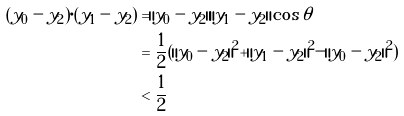Convert formula to latex. <formula><loc_0><loc_0><loc_500><loc_500>( y _ { 0 } - y _ { 2 } ) \cdot ( y _ { 1 } - y _ { 2 } ) & = \| y _ { 0 } - y _ { 2 } \| \| y _ { 1 } - y _ { 2 } \| \cos { \theta } \\ & = \frac { 1 } { 2 } ( \| y _ { 0 } - y _ { 2 } \| ^ { 2 } + \| y _ { 1 } - y _ { 2 } \| ^ { 2 } - \| y _ { 0 } - y _ { 2 } \| ^ { 2 } ) \\ & < \frac { 1 } { 2 }</formula> 